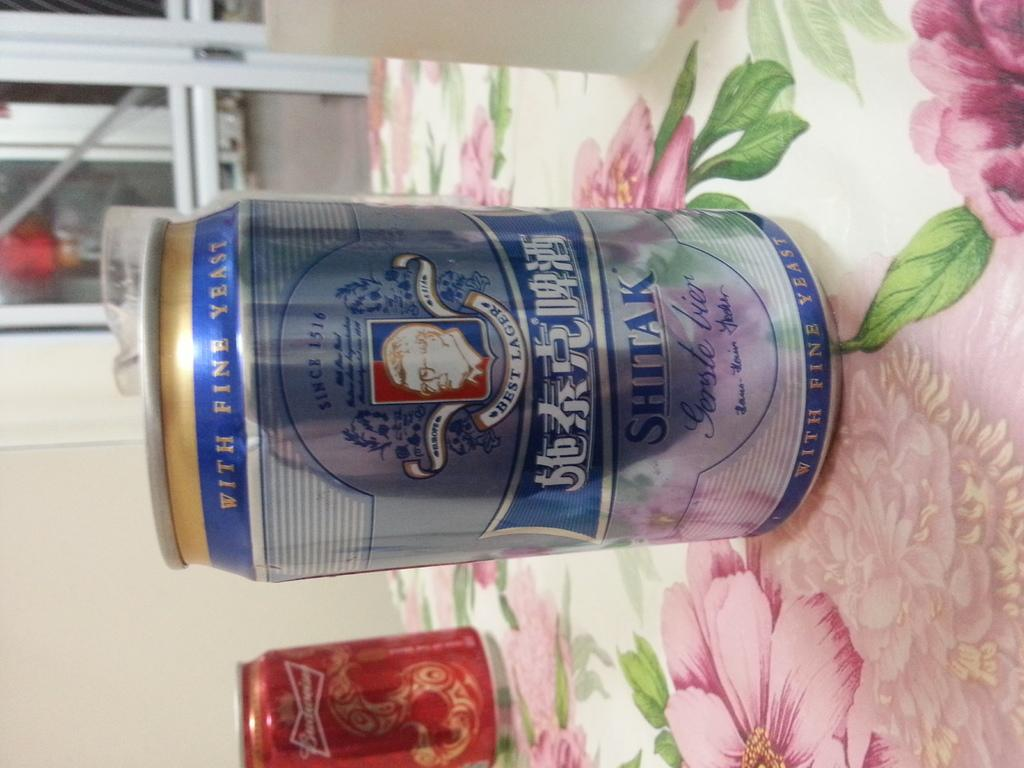<image>
Give a short and clear explanation of the subsequent image. A can of shitak lager is on the table with flower pattern cloth. 